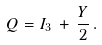Convert formula to latex. <formula><loc_0><loc_0><loc_500><loc_500>Q & = I _ { 3 } \, + \, \frac { Y } { 2 } \, .</formula> 